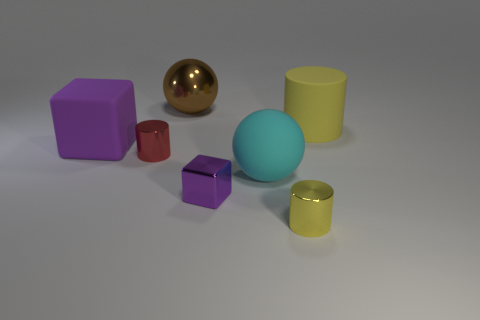Can you describe the different shapes and their colors in the image? Certainly! In the image, you can observe a variety of geometric shapes including a purple cube, a metallic gold sphere, a large olive green cylinder, a small deep red cylinder, a cyan sphere, a small purple cube, and a small gold cylinder. The shapes are arranged on a flat surface with a soft shadow cast beneath them. 